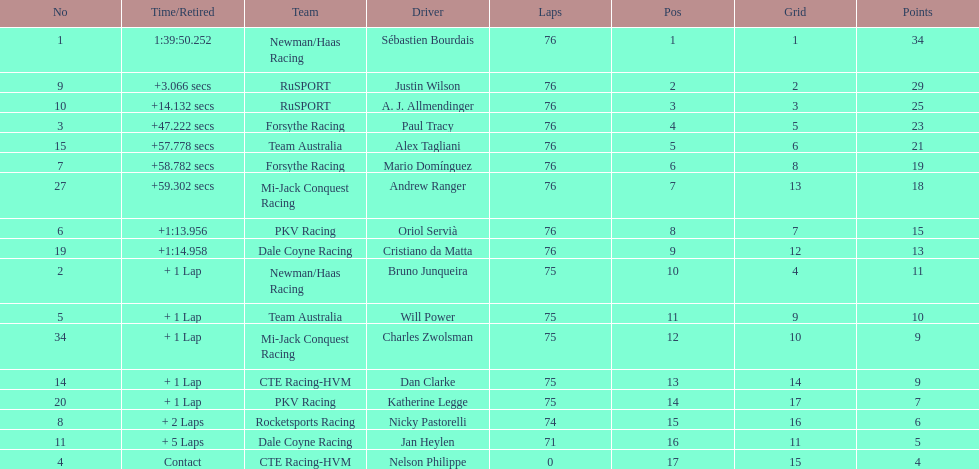How many positions are held by canada? 3. 